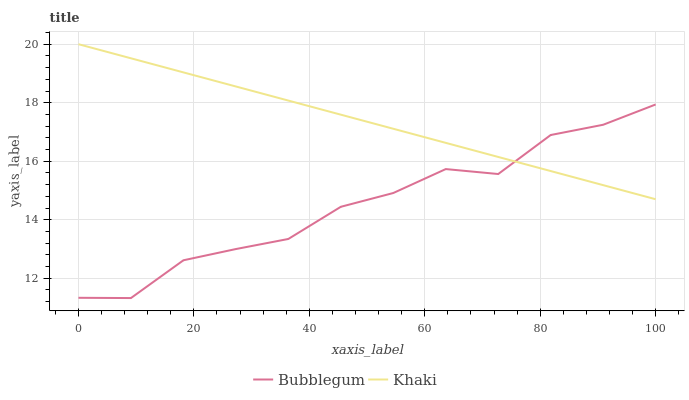Does Bubblegum have the minimum area under the curve?
Answer yes or no. Yes. Does Khaki have the maximum area under the curve?
Answer yes or no. Yes. Does Bubblegum have the maximum area under the curve?
Answer yes or no. No. Is Khaki the smoothest?
Answer yes or no. Yes. Is Bubblegum the roughest?
Answer yes or no. Yes. Is Bubblegum the smoothest?
Answer yes or no. No. Does Bubblegum have the lowest value?
Answer yes or no. Yes. Does Khaki have the highest value?
Answer yes or no. Yes. Does Bubblegum have the highest value?
Answer yes or no. No. Does Bubblegum intersect Khaki?
Answer yes or no. Yes. Is Bubblegum less than Khaki?
Answer yes or no. No. Is Bubblegum greater than Khaki?
Answer yes or no. No. 